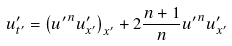<formula> <loc_0><loc_0><loc_500><loc_500>u ^ { \prime } _ { t ^ { \prime } } = \left ( { u ^ { \prime } } ^ { n } u ^ { \prime } _ { x ^ { \prime } } \right ) _ { x ^ { \prime } } + 2 \frac { n + 1 } { n } { u ^ { \prime } } ^ { n } u ^ { \prime } _ { x ^ { \prime } }</formula> 